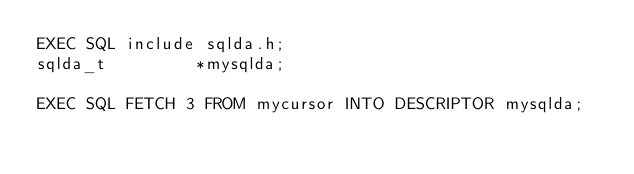<code> <loc_0><loc_0><loc_500><loc_500><_SQL_>EXEC SQL include sqlda.h;
sqlda_t         *mysqlda;

EXEC SQL FETCH 3 FROM mycursor INTO DESCRIPTOR mysqlda;
</code> 